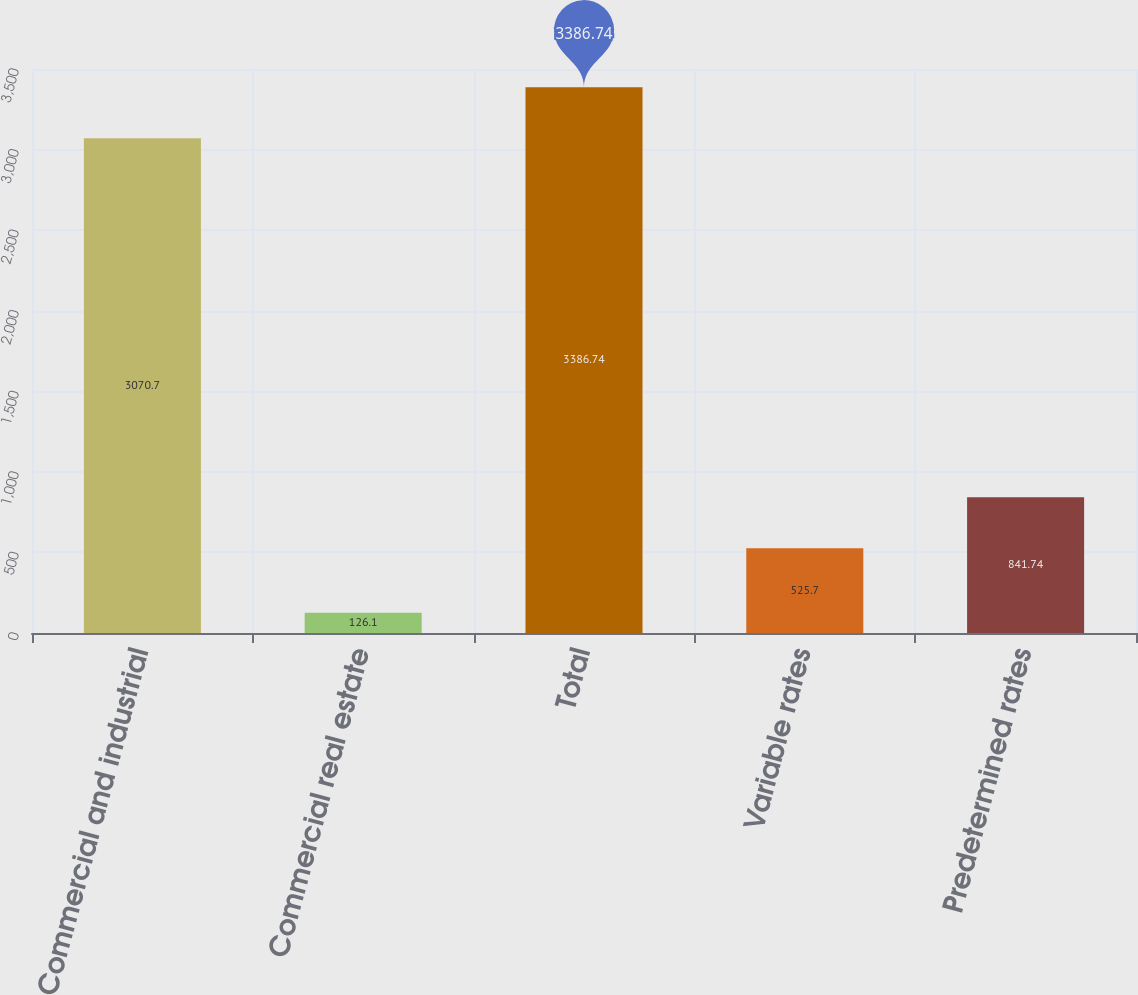Convert chart. <chart><loc_0><loc_0><loc_500><loc_500><bar_chart><fcel>Commercial and industrial<fcel>Commercial real estate<fcel>Total<fcel>Variable rates<fcel>Predetermined rates<nl><fcel>3070.7<fcel>126.1<fcel>3386.74<fcel>525.7<fcel>841.74<nl></chart> 